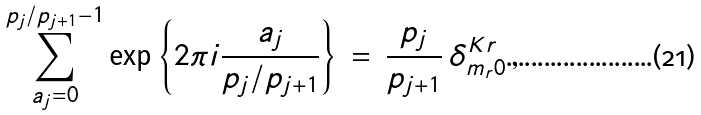<formula> <loc_0><loc_0><loc_500><loc_500>\sum _ { a _ { j } = 0 } ^ { p _ { j } / p _ { j + 1 } - 1 } \exp \left \{ 2 \pi i \frac { a _ { j } } { p _ { j } / p _ { j + 1 } } \right \} \, = \, \frac { p _ { j } } { p _ { j + 1 } } \, \delta ^ { K r } _ { m _ { r } 0 } \, ,</formula> 